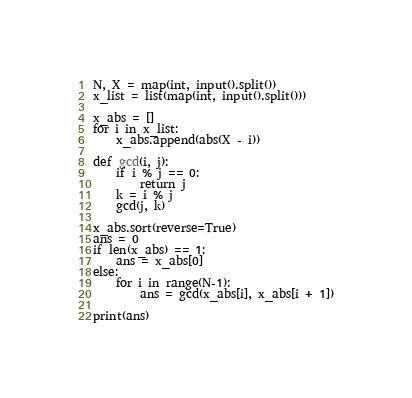Convert code to text. <code><loc_0><loc_0><loc_500><loc_500><_Python_>N, X = map(int, input().split())
x_list = list(map(int, input().split()))

x_abs = []
for i in x_list:
    x_abs.append(abs(X - i))

def gcd(i, j):
    if i % j == 0:
        return j
    k = i % j
    gcd(j, k)

x_abs.sort(reverse=True)
ans = 0
if len(x_abs) == 1:
    ans = x_abs[0]
else:
    for i in range(N-1):
        ans = gcd(x_abs[i], x_abs[i + 1])
    
print(ans)</code> 